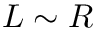<formula> <loc_0><loc_0><loc_500><loc_500>L \sim R</formula> 